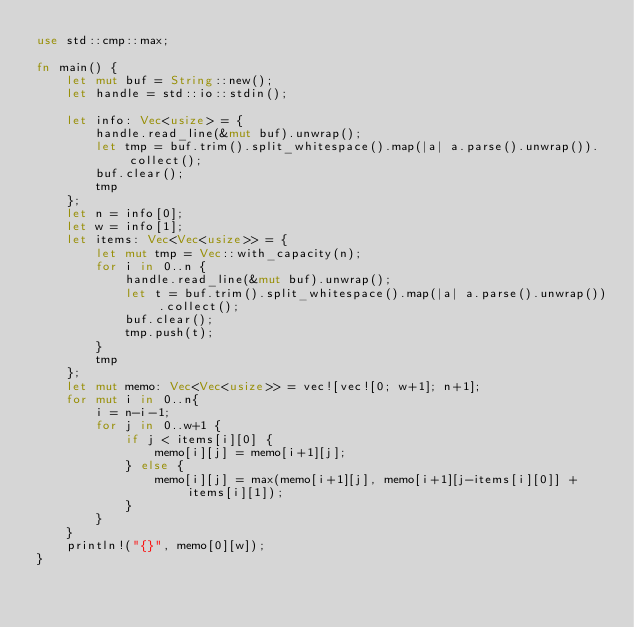<code> <loc_0><loc_0><loc_500><loc_500><_Rust_>use std::cmp::max;

fn main() {
    let mut buf = String::new();
    let handle = std::io::stdin();

    let info: Vec<usize> = {
        handle.read_line(&mut buf).unwrap();
        let tmp = buf.trim().split_whitespace().map(|a| a.parse().unwrap()).collect();
        buf.clear();
        tmp
    };
    let n = info[0];
    let w = info[1];
    let items: Vec<Vec<usize>> = {
        let mut tmp = Vec::with_capacity(n);
        for i in 0..n {
            handle.read_line(&mut buf).unwrap();
            let t = buf.trim().split_whitespace().map(|a| a.parse().unwrap()).collect();
            buf.clear();
            tmp.push(t);
        }
        tmp
    };
    let mut memo: Vec<Vec<usize>> = vec![vec![0; w+1]; n+1];
    for mut i in 0..n{
        i = n-i-1;
        for j in 0..w+1 {
            if j < items[i][0] {
                memo[i][j] = memo[i+1][j];
            } else {
                memo[i][j] = max(memo[i+1][j], memo[i+1][j-items[i][0]] + items[i][1]);
            }
        }
    }
    println!("{}", memo[0][w]);
}
</code> 